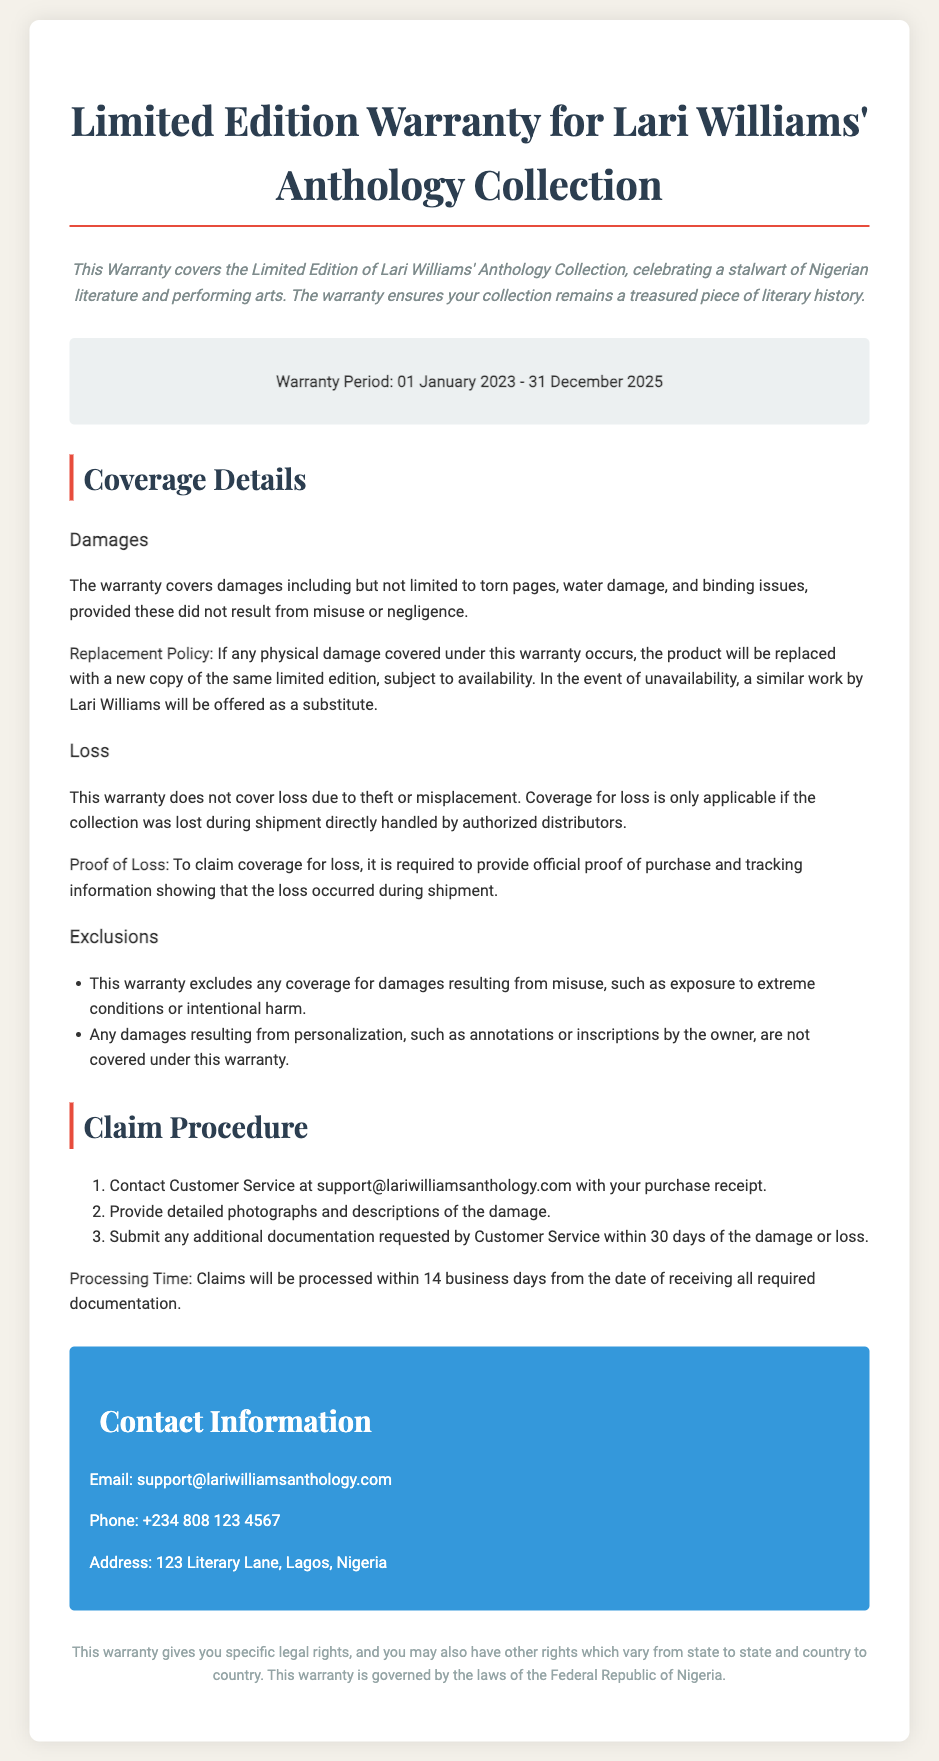What is the warranty period? The warranty period is stated in the document as the time frame during which the warranty is valid, specifically from January 1, 2023, to December 31, 2025.
Answer: 01 January 2023 - 31 December 2025 What types of damages are covered? The document outlines specific damages that are covered including torn pages, water damage, and binding issues.
Answer: Torn pages, water damage, and binding issues What is the replacement policy? The document specifies the conditions under which a damaged product will be replaced, including the offer of a similar work if the original is unavailable.
Answer: Replacement with a new copy Is loss due to theft covered? The document indicates whether loss due to theft is included in the coverage of the warranty.
Answer: No What must be provided for a loss claim? The document specifies that required documentation to make a claim for loss should include certain proofs to be considered valid.
Answer: Official proof of purchase and tracking information What are the exclusions mentioned in the warranty? The document lists situations and circumstances under which coverages are not provided.
Answer: Misuse and personalization How long is the claim processing time? The document covers the timeframe for processing claims once all documentation has been submitted.
Answer: 14 business days Who should be contacted for warranty claims? The document provides specific contact information for customer service where claims should be directed.
Answer: Customer Service at support@lariwilliamsanthology.com 